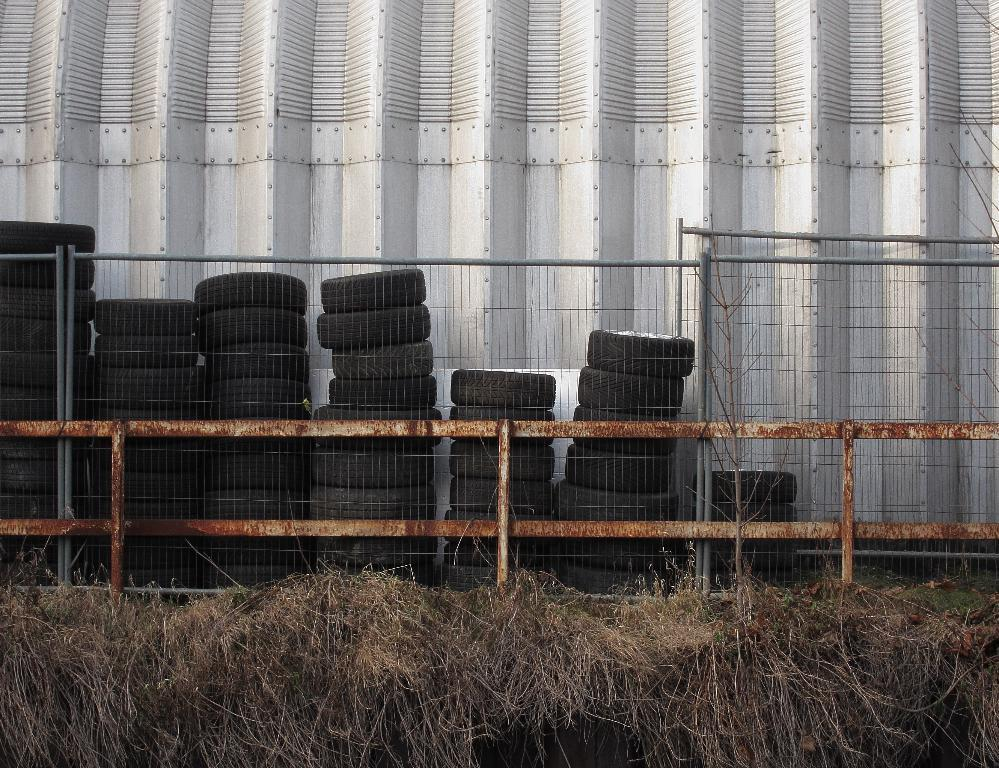What type of vegetation can be seen at the bottom side of the image? There is dried grass at the bottom side of the image. What separates the image into two distinct sections? There is a boundary in the center of the image. What objects are located inside the boundary? There are tires inside the boundary. How many errors can be found in the image? There is no mention of any errors in the image, so it is not possible to determine the number of errors. What type of mark is visible on the tires in the image? There is no mention of any marks on the tires in the image, so it is not possible to determine the type of mark. 